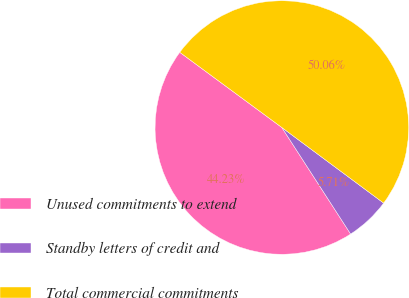Convert chart. <chart><loc_0><loc_0><loc_500><loc_500><pie_chart><fcel>Unused commitments to extend<fcel>Standby letters of credit and<fcel>Total commercial commitments<nl><fcel>44.23%<fcel>5.71%<fcel>50.06%<nl></chart> 